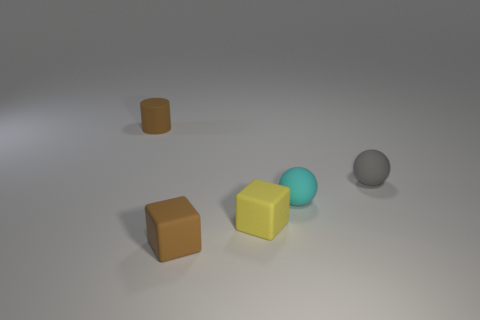Are the ball on the right side of the tiny cyan matte thing and the small cylinder made of the same material?
Your answer should be compact. Yes. What is the size of the matte thing that is both left of the tiny yellow matte block and in front of the small brown cylinder?
Your response must be concise. Small. How big is the brown rubber object that is in front of the tiny cyan thing?
Your response must be concise. Small. The tiny brown object on the right side of the tiny brown matte cylinder that is to the left of the small brown matte thing that is on the right side of the cylinder is what shape?
Your answer should be compact. Cube. How many other things are the same shape as the cyan matte thing?
Give a very brief answer. 1. What number of rubber objects are brown cylinders or big brown cylinders?
Offer a terse response. 1. What is the material of the brown object on the left side of the small brown object that is to the right of the tiny brown rubber cylinder?
Your answer should be very brief. Rubber. Are there more tiny matte objects that are to the right of the cyan sphere than small cyan matte things?
Your answer should be very brief. No. Are there any yellow cubes made of the same material as the cylinder?
Keep it short and to the point. Yes. There is a small rubber thing to the right of the cyan thing; is it the same shape as the tiny cyan object?
Provide a short and direct response. Yes. 